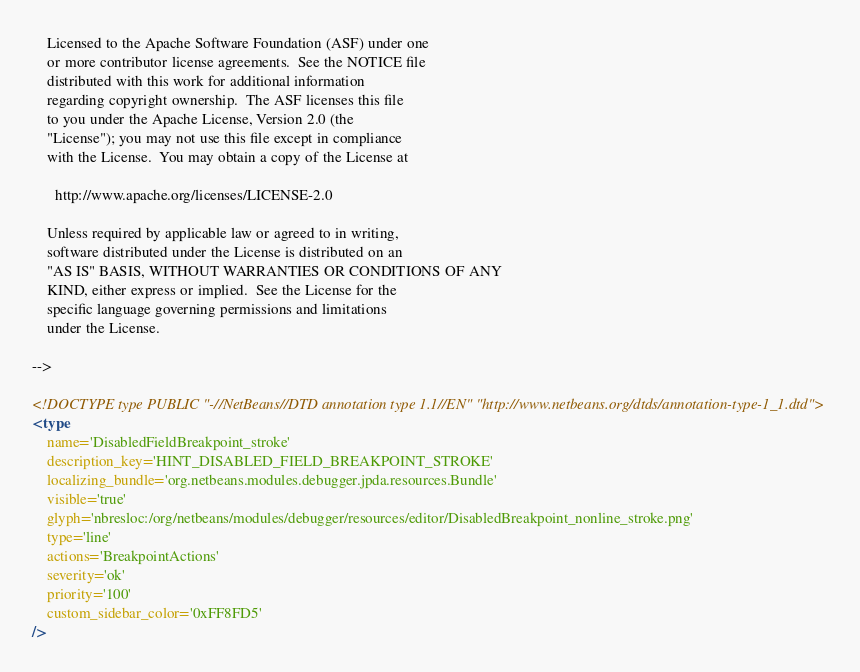<code> <loc_0><loc_0><loc_500><loc_500><_XML_>
    Licensed to the Apache Software Foundation (ASF) under one
    or more contributor license agreements.  See the NOTICE file
    distributed with this work for additional information
    regarding copyright ownership.  The ASF licenses this file
    to you under the Apache License, Version 2.0 (the
    "License"); you may not use this file except in compliance
    with the License.  You may obtain a copy of the License at

      http://www.apache.org/licenses/LICENSE-2.0

    Unless required by applicable law or agreed to in writing,
    software distributed under the License is distributed on an
    "AS IS" BASIS, WITHOUT WARRANTIES OR CONDITIONS OF ANY
    KIND, either express or implied.  See the License for the
    specific language governing permissions and limitations
    under the License.

-->

<!DOCTYPE type PUBLIC "-//NetBeans//DTD annotation type 1.1//EN" "http://www.netbeans.org/dtds/annotation-type-1_1.dtd">
<type
    name='DisabledFieldBreakpoint_stroke'
    description_key='HINT_DISABLED_FIELD_BREAKPOINT_STROKE'
    localizing_bundle='org.netbeans.modules.debugger.jpda.resources.Bundle'
    visible='true'
    glyph='nbresloc:/org/netbeans/modules/debugger/resources/editor/DisabledBreakpoint_nonline_stroke.png'
    type='line'
    actions='BreakpointActions'
    severity='ok'
    priority='100'
    custom_sidebar_color='0xFF8FD5'
/>
</code> 